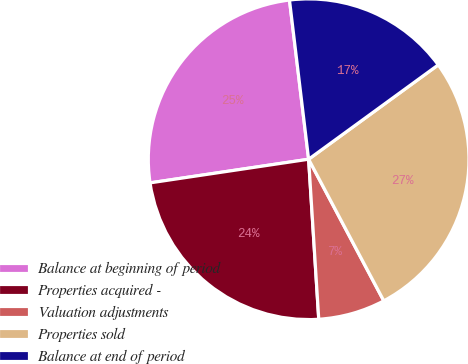<chart> <loc_0><loc_0><loc_500><loc_500><pie_chart><fcel>Balance at beginning of period<fcel>Properties acquired -<fcel>Valuation adjustments<fcel>Properties sold<fcel>Balance at end of period<nl><fcel>25.45%<fcel>23.65%<fcel>6.76%<fcel>27.25%<fcel>16.89%<nl></chart> 